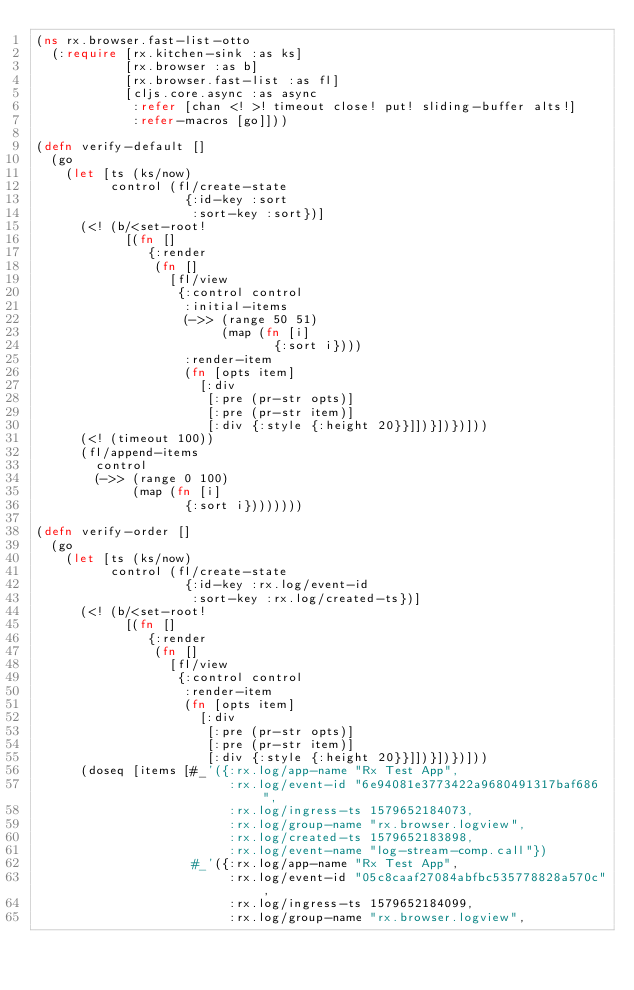Convert code to text. <code><loc_0><loc_0><loc_500><loc_500><_Clojure_>(ns rx.browser.fast-list-otto
  (:require [rx.kitchen-sink :as ks]
            [rx.browser :as b]
            [rx.browser.fast-list :as fl]
            [cljs.core.async :as async
             :refer [chan <! >! timeout close! put! sliding-buffer alts!]
             :refer-macros [go]]))

(defn verify-default []
  (go
    (let [ts (ks/now)
          control (fl/create-state
                    {:id-key :sort
                     :sort-key :sort})]
      (<! (b/<set-root!
            [(fn []
               {:render
                (fn []
                  [fl/view
                   {:control control
                    :initial-items
                    (->> (range 50 51)
                         (map (fn [i]
                                {:sort i})))
                    :render-item
                    (fn [opts item]
                      [:div
                       [:pre (pr-str opts)]
                       [:pre (pr-str item)]
                       [:div {:style {:height 20}}]])}])})]))
      (<! (timeout 100))
      (fl/append-items
        control
        (->> (range 0 100)
             (map (fn [i]
                    {:sort i})))))))

(defn verify-order []
  (go
    (let [ts (ks/now)
          control (fl/create-state
                    {:id-key :rx.log/event-id
                     :sort-key :rx.log/created-ts})]
      (<! (b/<set-root!
            [(fn []
               {:render
                (fn []
                  [fl/view
                   {:control control
                    :render-item
                    (fn [opts item]
                      [:div
                       [:pre (pr-str opts)]
                       [:pre (pr-str item)]
                       [:div {:style {:height 20}}]])}])})]))
      (doseq [items [#_'({:rx.log/app-name "Rx Test App",
                          :rx.log/event-id "6e94081e3773422a9680491317baf686",
                          :rx.log/ingress-ts 1579652184073,
                          :rx.log/group-name "rx.browser.logview",
                          :rx.log/created-ts 1579652183898,
                          :rx.log/event-name "log-stream-comp.call"})
                     #_'({:rx.log/app-name "Rx Test App",
                          :rx.log/event-id "05c8caaf27084abfbc535778828a570c",
                          :rx.log/ingress-ts 1579652184099,
                          :rx.log/group-name "rx.browser.logview",</code> 